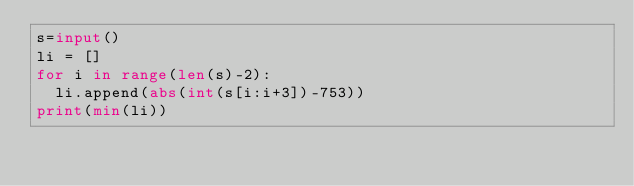<code> <loc_0><loc_0><loc_500><loc_500><_Python_>s=input()
li = []
for i in range(len(s)-2):
  li.append(abs(int(s[i:i+3])-753))
print(min(li))</code> 